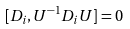Convert formula to latex. <formula><loc_0><loc_0><loc_500><loc_500>[ D _ { i } , U ^ { - 1 } D _ { i } U ] = 0</formula> 